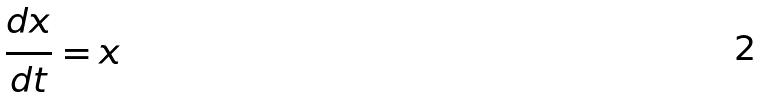<formula> <loc_0><loc_0><loc_500><loc_500>\frac { d x } { d t } = x</formula> 